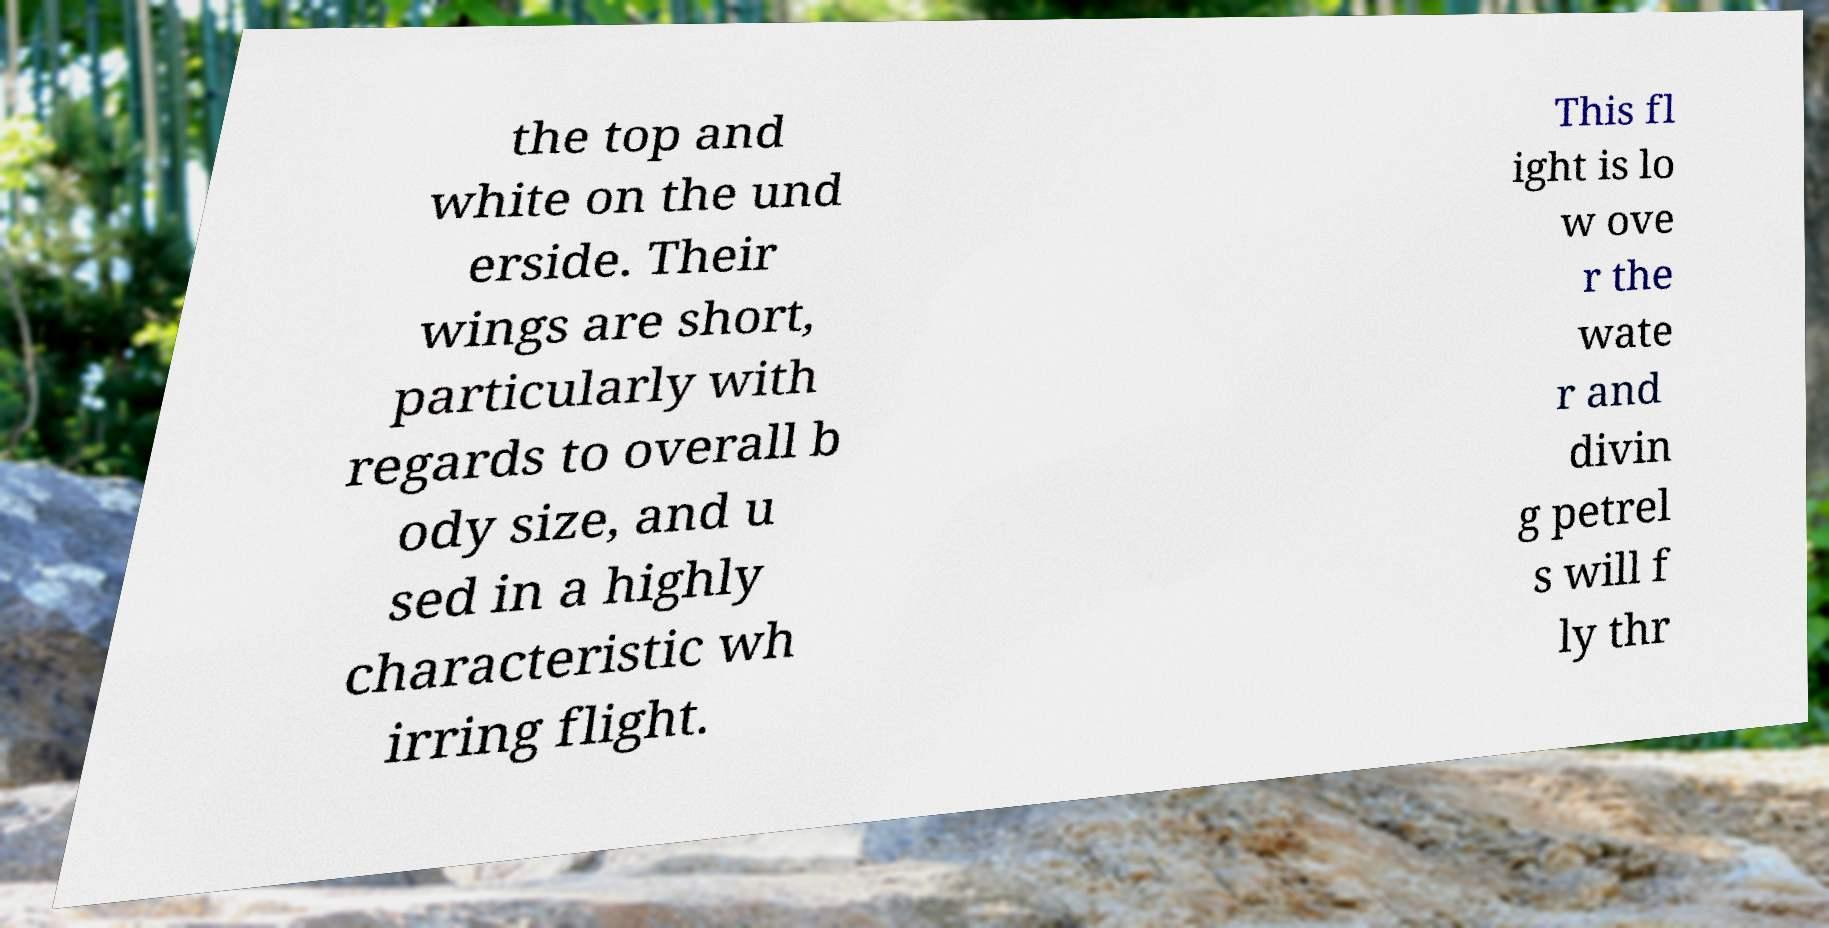There's text embedded in this image that I need extracted. Can you transcribe it verbatim? the top and white on the und erside. Their wings are short, particularly with regards to overall b ody size, and u sed in a highly characteristic wh irring flight. This fl ight is lo w ove r the wate r and divin g petrel s will f ly thr 